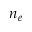<formula> <loc_0><loc_0><loc_500><loc_500>n _ { e }</formula> 